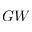Convert formula to latex. <formula><loc_0><loc_0><loc_500><loc_500>G W</formula> 